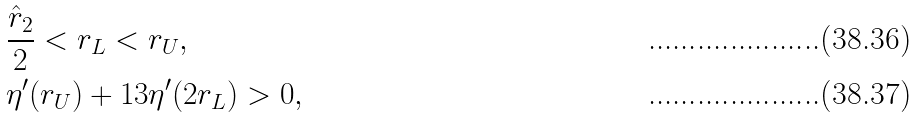<formula> <loc_0><loc_0><loc_500><loc_500>& \frac { \hat { r } _ { 2 } } { 2 } < r _ { L } < r _ { U } , \\ & \eta ^ { \prime } ( r _ { U } ) + 1 3 \eta ^ { \prime } ( 2 r _ { L } ) > 0 ,</formula> 